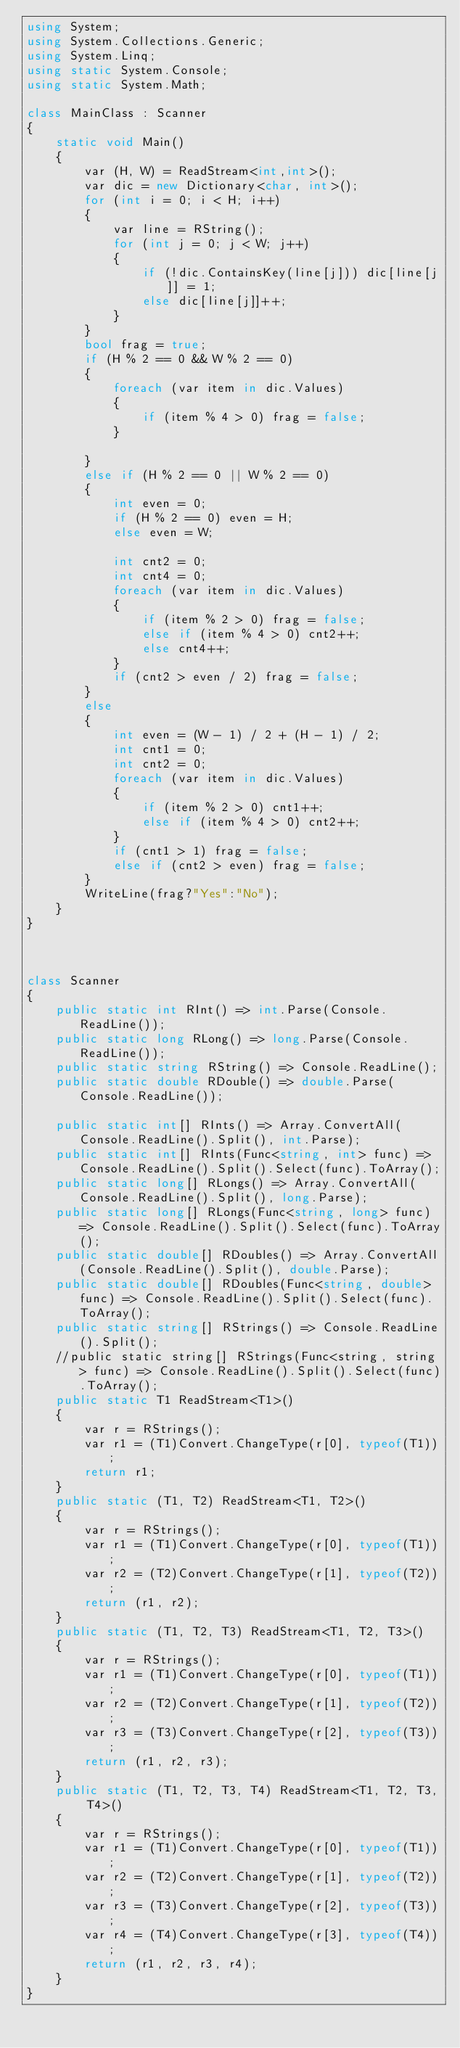<code> <loc_0><loc_0><loc_500><loc_500><_C#_>using System;
using System.Collections.Generic;
using System.Linq;
using static System.Console;
using static System.Math;

class MainClass : Scanner
{
    static void Main()
    {
        var (H, W) = ReadStream<int,int>();
        var dic = new Dictionary<char, int>();
        for (int i = 0; i < H; i++)
        {
            var line = RString();
            for (int j = 0; j < W; j++)
            {
                if (!dic.ContainsKey(line[j])) dic[line[j]] = 1;
                else dic[line[j]]++;
            }
        }
        bool frag = true;
        if (H % 2 == 0 && W % 2 == 0)
        {
            foreach (var item in dic.Values)
            {
                if (item % 4 > 0) frag = false;
            }

        }
        else if (H % 2 == 0 || W % 2 == 0)
        {
            int even = 0;
            if (H % 2 == 0) even = H;
            else even = W;

            int cnt2 = 0;
            int cnt4 = 0;
            foreach (var item in dic.Values)
            {
                if (item % 2 > 0) frag = false;
                else if (item % 4 > 0) cnt2++;
                else cnt4++;
            }
            if (cnt2 > even / 2) frag = false;
        }
        else
        {
            int even = (W - 1) / 2 + (H - 1) / 2;
            int cnt1 = 0;
            int cnt2 = 0;
            foreach (var item in dic.Values)
            {
                if (item % 2 > 0) cnt1++;
                else if (item % 4 > 0) cnt2++;
            }
            if (cnt1 > 1) frag = false;
            else if (cnt2 > even) frag = false;
        }
        WriteLine(frag?"Yes":"No");
    }
}



class Scanner
{
    public static int RInt() => int.Parse(Console.ReadLine());
    public static long RLong() => long.Parse(Console.ReadLine());
    public static string RString() => Console.ReadLine();
    public static double RDouble() => double.Parse(Console.ReadLine());

    public static int[] RInts() => Array.ConvertAll(Console.ReadLine().Split(), int.Parse);
    public static int[] RInts(Func<string, int> func) => Console.ReadLine().Split().Select(func).ToArray();
    public static long[] RLongs() => Array.ConvertAll(Console.ReadLine().Split(), long.Parse);
    public static long[] RLongs(Func<string, long> func) => Console.ReadLine().Split().Select(func).ToArray();
    public static double[] RDoubles() => Array.ConvertAll(Console.ReadLine().Split(), double.Parse);
    public static double[] RDoubles(Func<string, double> func) => Console.ReadLine().Split().Select(func).ToArray();
    public static string[] RStrings() => Console.ReadLine().Split();
    //public static string[] RStrings(Func<string, string> func) => Console.ReadLine().Split().Select(func).ToArray();
    public static T1 ReadStream<T1>()
    {
        var r = RStrings();
        var r1 = (T1)Convert.ChangeType(r[0], typeof(T1));
        return r1;
    }
    public static (T1, T2) ReadStream<T1, T2>()
    {
        var r = RStrings();
        var r1 = (T1)Convert.ChangeType(r[0], typeof(T1));
        var r2 = (T2)Convert.ChangeType(r[1], typeof(T2));
        return (r1, r2);
    }
    public static (T1, T2, T3) ReadStream<T1, T2, T3>()
    {
        var r = RStrings();
        var r1 = (T1)Convert.ChangeType(r[0], typeof(T1));
        var r2 = (T2)Convert.ChangeType(r[1], typeof(T2));
        var r3 = (T3)Convert.ChangeType(r[2], typeof(T3));
        return (r1, r2, r3);
    }
    public static (T1, T2, T3, T4) ReadStream<T1, T2, T3, T4>()
    {
        var r = RStrings();
        var r1 = (T1)Convert.ChangeType(r[0], typeof(T1));
        var r2 = (T2)Convert.ChangeType(r[1], typeof(T2));
        var r3 = (T3)Convert.ChangeType(r[2], typeof(T3));
        var r4 = (T4)Convert.ChangeType(r[3], typeof(T4));
        return (r1, r2, r3, r4);
    }
}</code> 